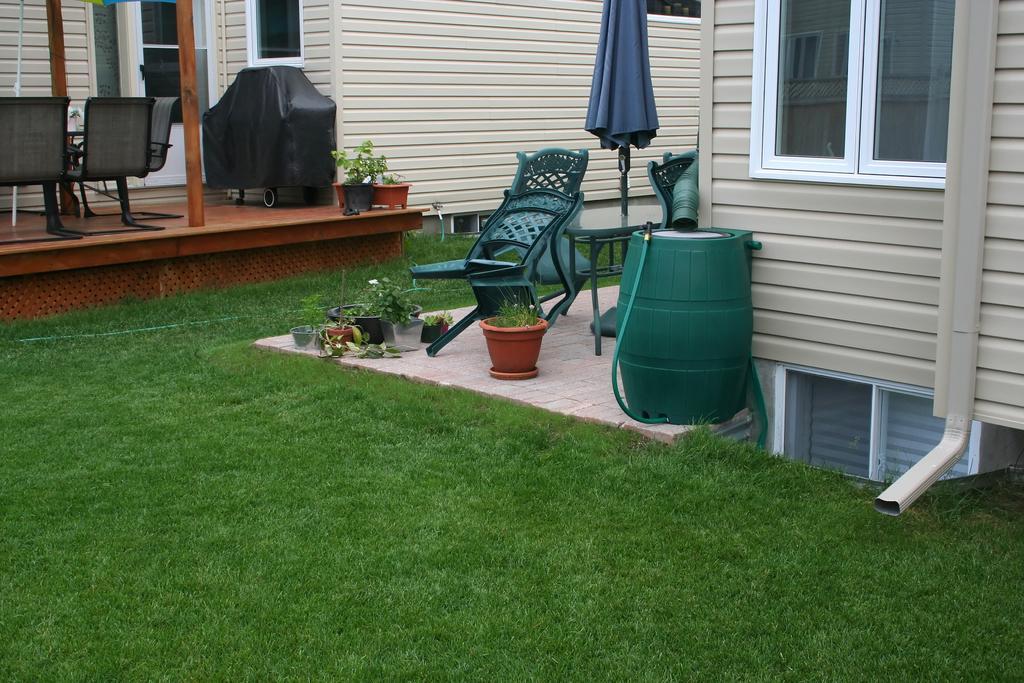How would you summarize this image in a sentence or two? In this image I can see the grass and the building. There are some flower pots,drum,chairs and the table. 